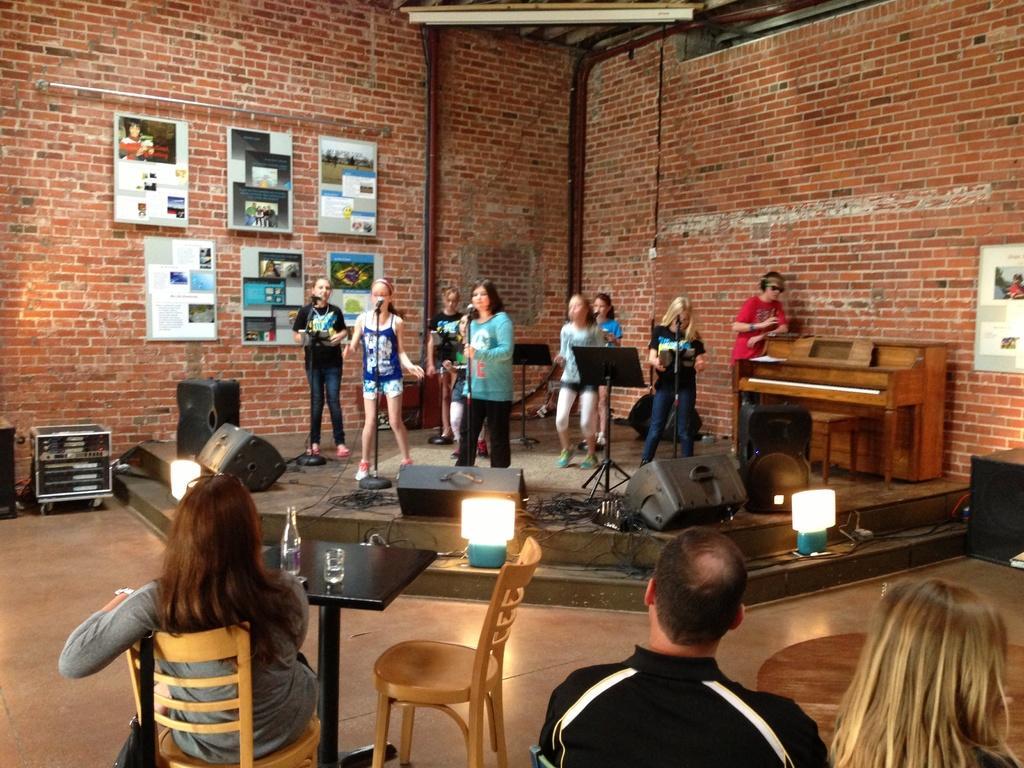In one or two sentences, can you explain what this image depicts? In this picture we can see a group of people here in front woman is sitting on chair and in front of her table and on table we can see bottle and glass and here the people are singing holding mic in their hands and they are standing on stage and in the background we can see wall, frames on that wall, pipes, on stage we have speakers. 